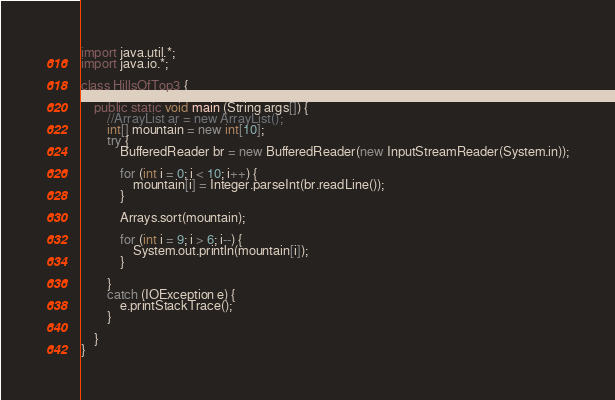<code> <loc_0><loc_0><loc_500><loc_500><_Java_>import java.util.*;
import java.io.*;

class HillsOfTop3 {

    public static void main (String args[]) {
        //ArrayList ar = new ArrayList();
		int[] mountain = new int[10];
		try {
			BufferedReader br = new BufferedReader(new InputStreamReader(System.in));
			
			for (int i = 0; i < 10; i++) {
				mountain[i] = Integer.parseInt(br.readLine());
			}
			
			Arrays.sort(mountain);
			
			for (int i = 9; i > 6; i--) {
				System.out.println(mountain[i]);
			}
			
		}
		catch (IOException e) {
			e.printStackTrace();
		}
		
    }
}</code> 